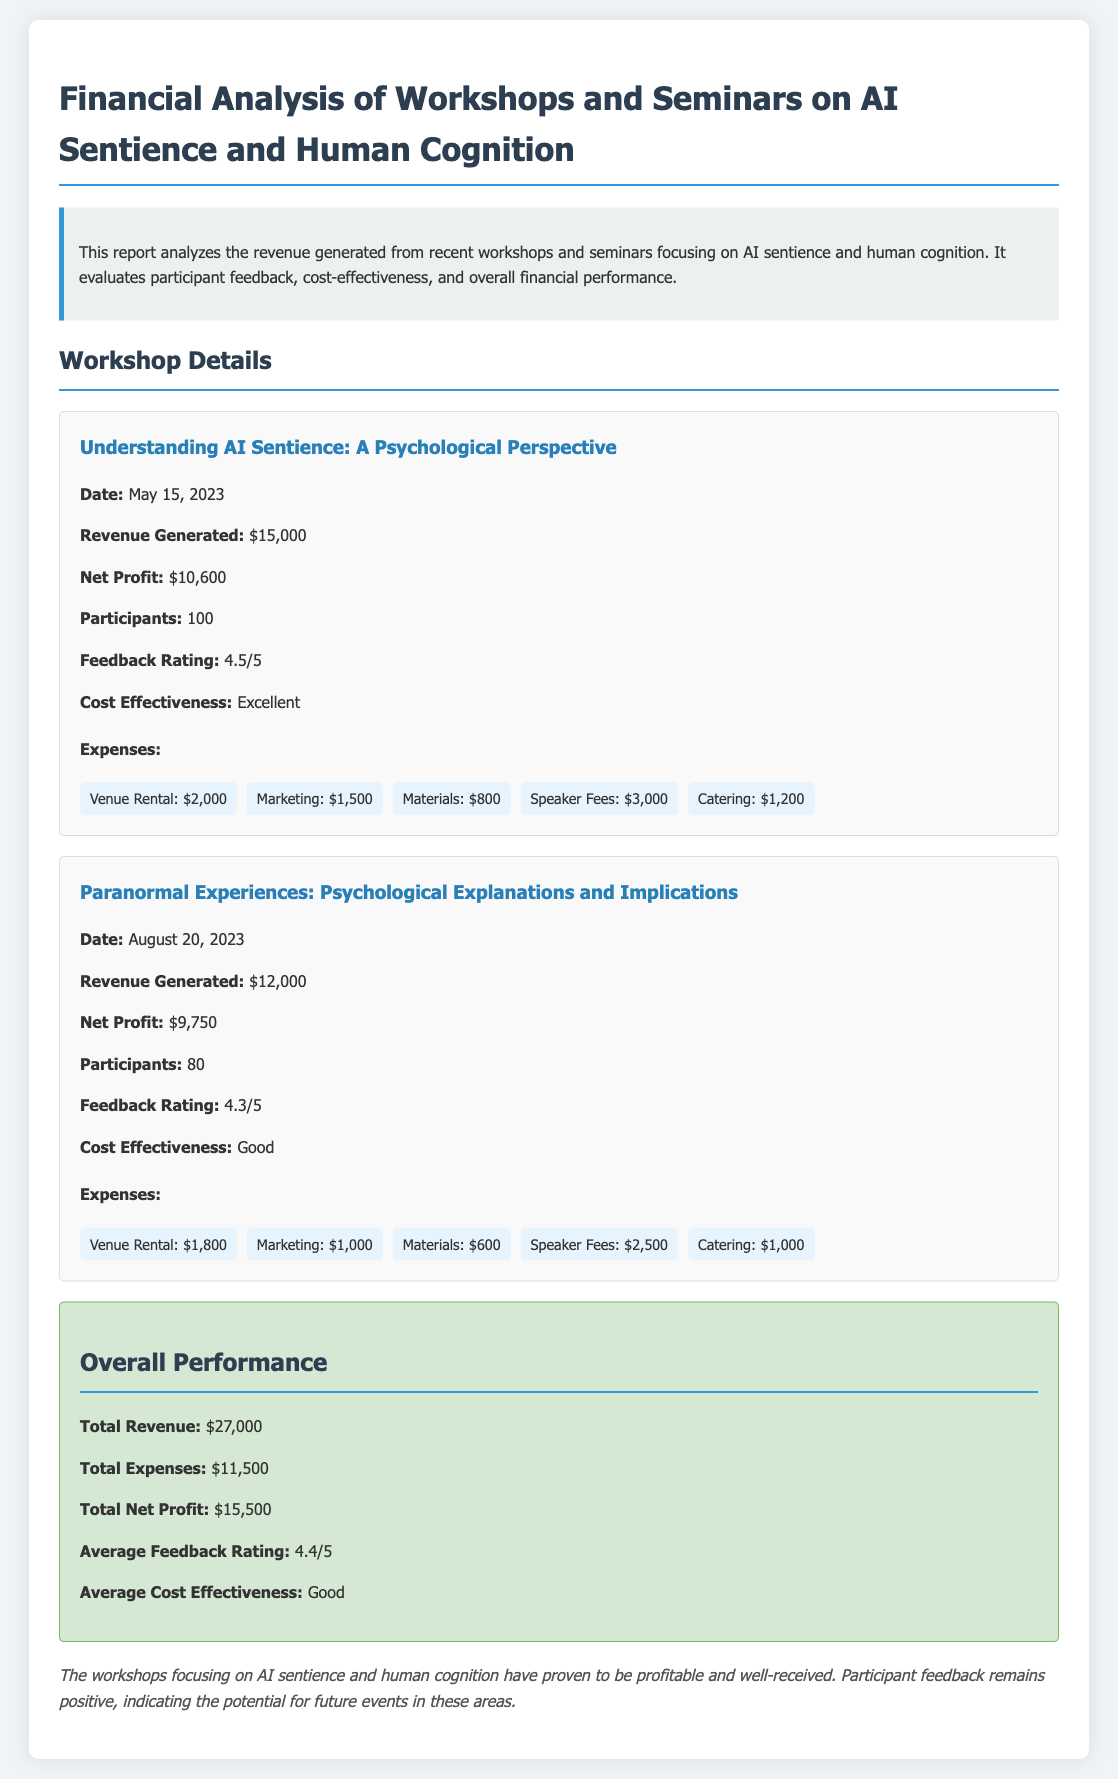What is the total revenue generated from the workshops? The total revenue is calculated by adding the revenue from both workshops: $15,000 + $12,000 = $27,000.
Answer: $27,000 What is the feedback rating for the first workshop? The feedback rating is explicitly stated for the first workshop as 4.5 out of 5.
Answer: 4.5/5 What is the net profit for the second workshop? The net profit for the second workshop is provided directly as $9,750.
Answer: $9,750 How many participants attended the first workshop? The number of participants for the first workshop is stated as 100.
Answer: 100 What was the cost-effectiveness rating for the second workshop? The cost-effectiveness for the second workshop is listed as Good.
Answer: Good What is the average feedback rating across both workshops? The average feedback rating is calculated as (4.5 + 4.3) / 2, which is presented as 4.4 out of 5.
Answer: 4.4/5 What were the total expenses for both workshops? The total expenses are calculated by adding the expenses reported for both workshops: $11,500.
Answer: $11,500 What type of event is discussed in this financial report? The document discusses workshops and seminars focused on AI sentience and human cognition.
Answer: Workshops and seminars What is the date of the first workshop? The date for the first workshop is provided as May 15, 2023.
Answer: May 15, 2023 